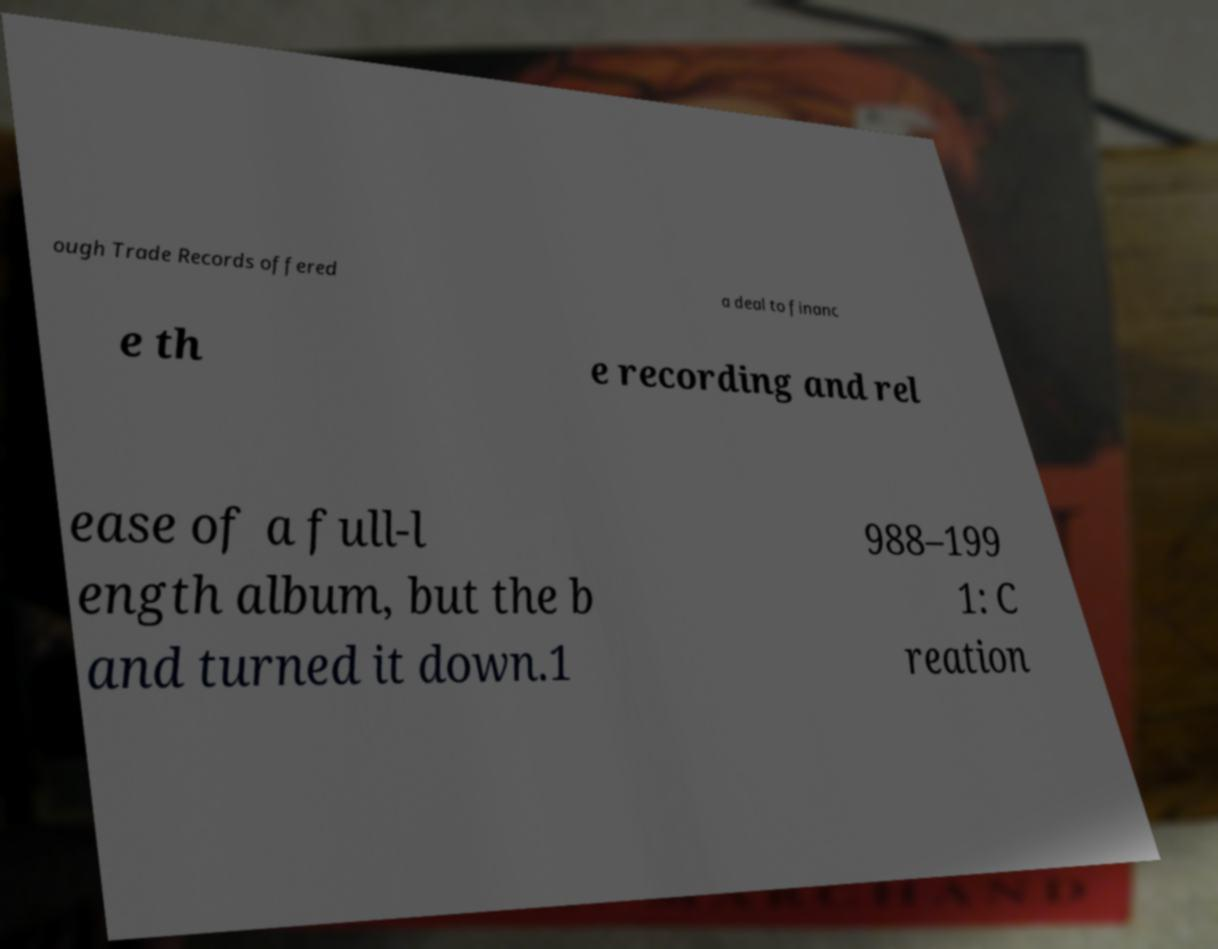Could you assist in decoding the text presented in this image and type it out clearly? ough Trade Records offered a deal to financ e th e recording and rel ease of a full-l ength album, but the b and turned it down.1 988–199 1: C reation 